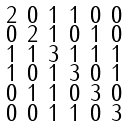Convert formula to latex. <formula><loc_0><loc_0><loc_500><loc_500>\begin{smallmatrix} 2 & 0 & 1 & 1 & 0 & 0 \\ 0 & 2 & 1 & 0 & 1 & 0 \\ 1 & 1 & 3 & 1 & 1 & 1 \\ 1 & 0 & 1 & 3 & 0 & 1 \\ 0 & 1 & 1 & 0 & 3 & 0 \\ 0 & 0 & 1 & 1 & 0 & 3 \end{smallmatrix}</formula> 